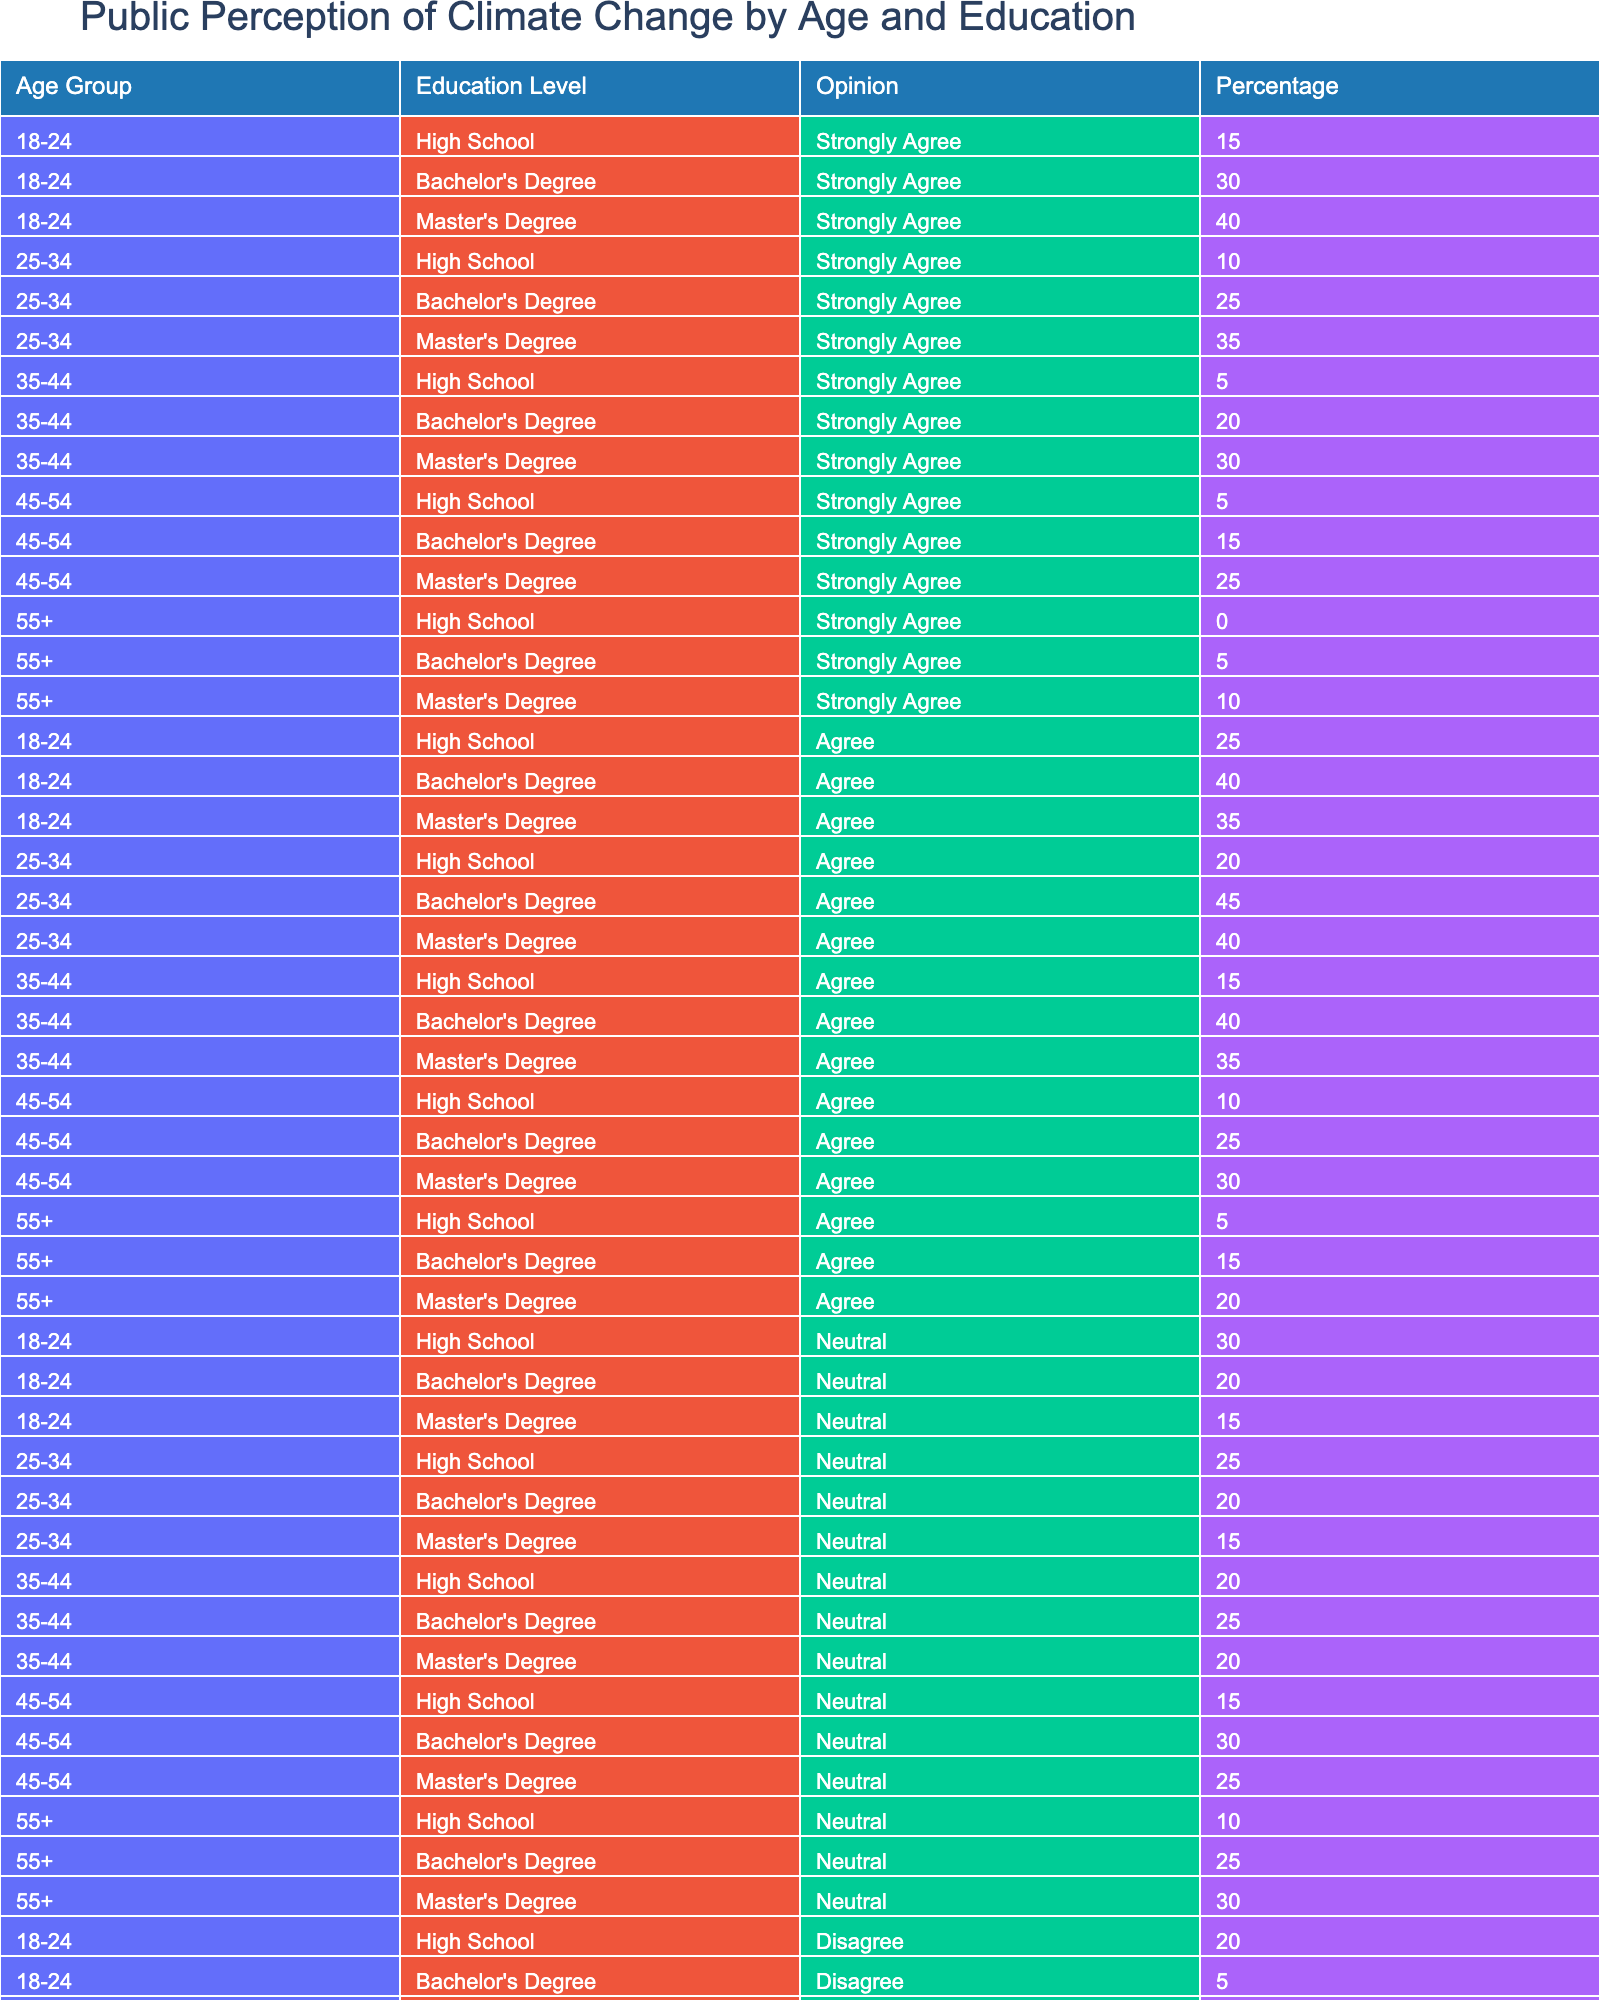What percentage of 18-24 year-olds with a Bachelor's degree strongly agree that climate change is a significant issue? From the table, we see that 30% of the 18-24 age group with a Bachelor's degree selected "Strongly Agree."
Answer: 30% Which education level has the highest percentage of respondents who strongly disagree with the idea of climate change for the age group 55+? The table shows that among the 55+ age group, "High School" has the highest percentage of Strongly Disagree at 30%.
Answer: High School What is the total percentage of respondents aged 35-44 with a Master's degree who either agree or strongly agree with climate change? For the 35-44 age group with a Master's degree, 30% Strongly Agree and 35% Agree. Adding those together gives 30 + 35 = 65%.
Answer: 65% Is it true that more individuals aged 45-54 with a Bachelor's degree agree than disagree with climate change? From the table, we see that 15% Strongly Agree and 25% Agree, totaling 40%, while 20% Disagree and 10% Strongly Disagree, totaling 30%. Therefore, it is true that more agree than disagree.
Answer: Yes For the age group 25-34 with a Master's degree, what is the percentage of those who feel neutral about climate change? The table indicates that 15% of the 25-34 age group with a Master's degree selected Neutral.
Answer: 15% 